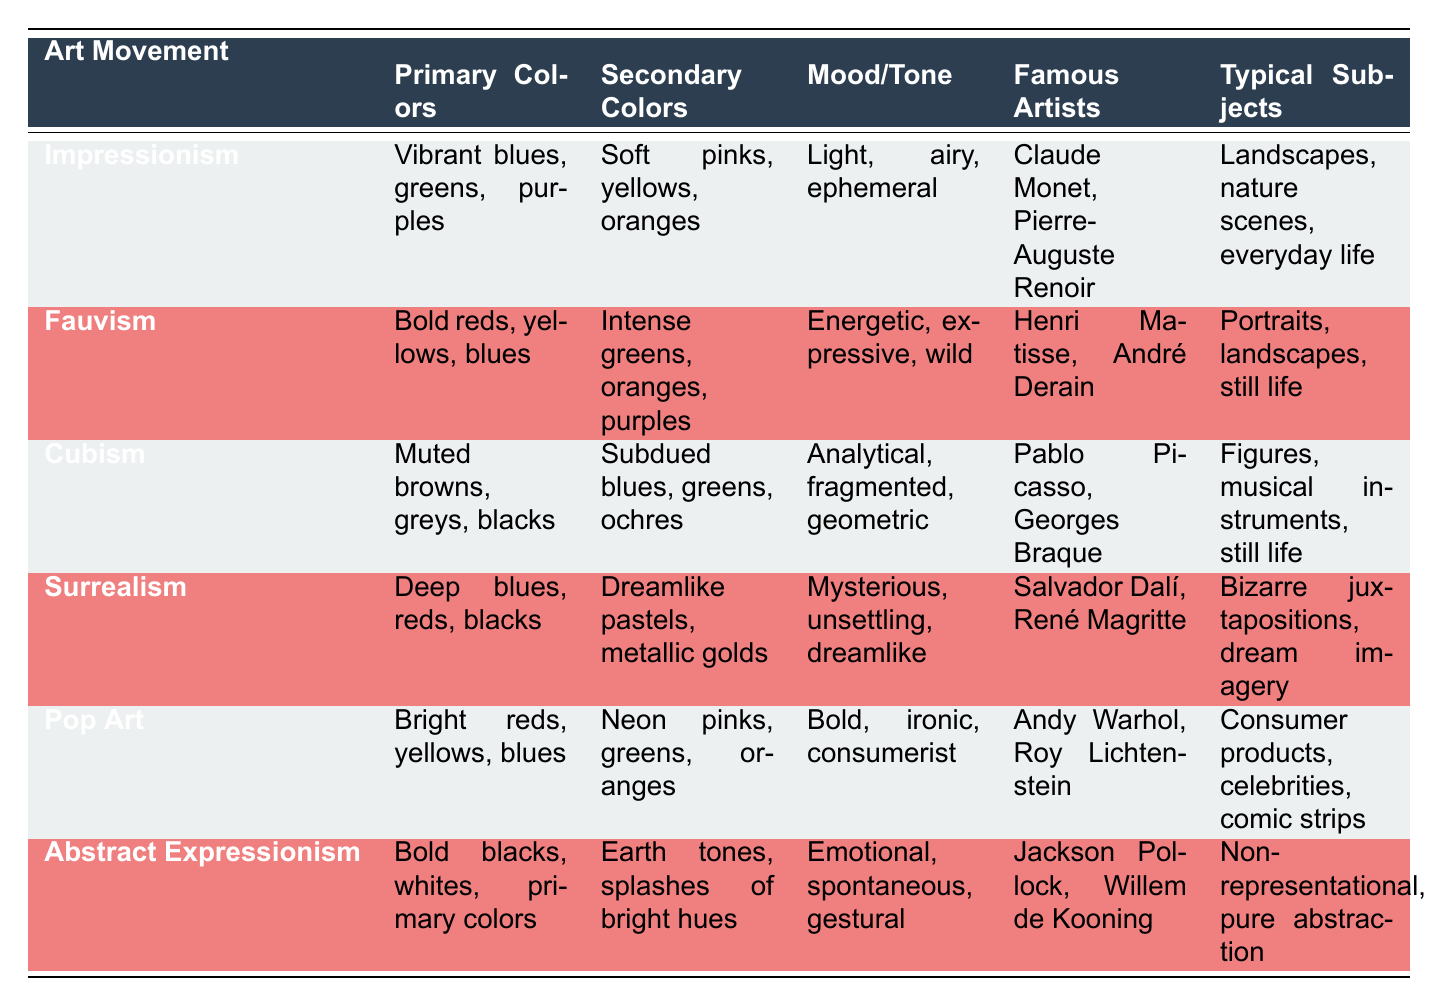What are the primary colors used in Cubism? The primary colors listed for Cubism in the table are muted browns, greys, and blacks.
Answer: Muted browns, greys, blacks Which art movement is characterized by an energetic and wild mood? The mood described as energetic and wild corresponds to Fauvism in the table.
Answer: Fauvism True or False: Impressionism uses bold colors primarily. Impressionism is described as using vibrant colors but they are not characterized as bold; therefore, it is false that it primarily uses bold colors.
Answer: False What is the typical subject matter in Pop Art? According to the table, the typical subjects in Pop Art include consumer products, celebrities, and comic strips.
Answer: Consumer products, celebrities, comic strips Which two art movements have a mysterious tone in their mood? The table lists Surrealism with a mysterious tone and also includes a deeper element of mystery. However, only Surrealism is explicitly stated as having a mysterious mood; therefore, only one applies here.
Answer: Surrealism What is the average number of famous artists represented in the table per art movement? There are six art movements and a total of 12 famous artists listed. To find the average, you divide the total number of artists by the number of movements: 12/6 = 2.
Answer: 2 Which art movement features both deep blues and blacks as primary colors? The art movement with deep blues and blacks listed as primary colors is Surrealism.
Answer: Surrealism Is it true that the color palette of Abstract Expressionism includes only primary colors? The palette of Abstract Expressionism includes not only primary colors but also bold blacks and whites; thus, the statement is false.
Answer: False What distinguishes the mood of Abstract Expressionism from Impressionism? Abstract Expressionism is characterized as emotional, spontaneous, and gestural, while Impressionism's mood is described as light, airy, and ephemeral, showing a significant difference in tone.
Answer: Emotional, spontaneous, and gestural vs. light, airy, ephemeral 